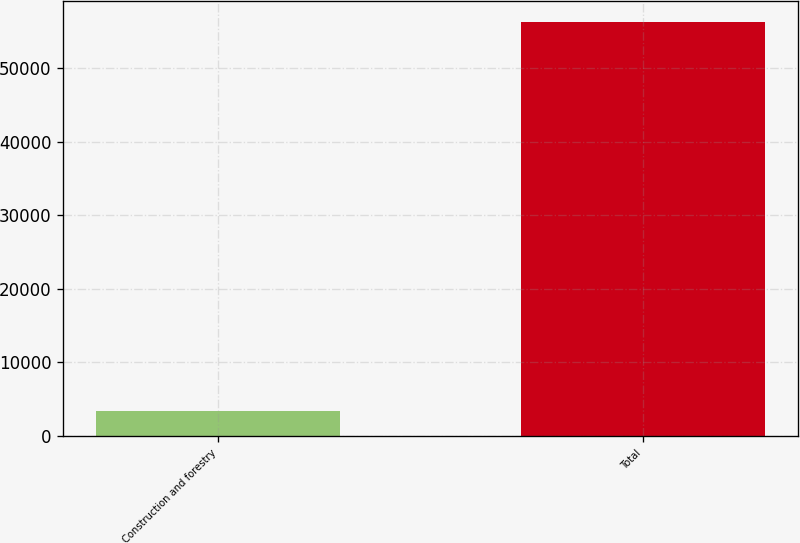Convert chart to OTSL. <chart><loc_0><loc_0><loc_500><loc_500><bar_chart><fcel>Construction and forestry<fcel>Total<nl><fcel>3365<fcel>56266<nl></chart> 